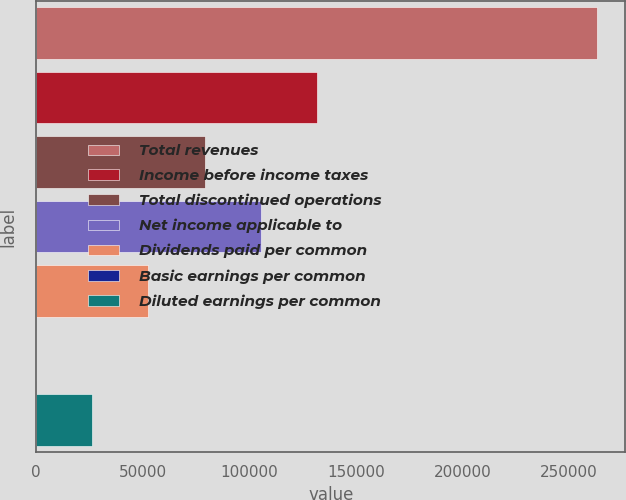Convert chart to OTSL. <chart><loc_0><loc_0><loc_500><loc_500><bar_chart><fcel>Total revenues<fcel>Income before income taxes<fcel>Total discontinued operations<fcel>Net income applicable to<fcel>Dividends paid per common<fcel>Basic earnings per common<fcel>Diluted earnings per common<nl><fcel>263265<fcel>131633<fcel>78979.6<fcel>105306<fcel>52653.1<fcel>0.14<fcel>26326.6<nl></chart> 